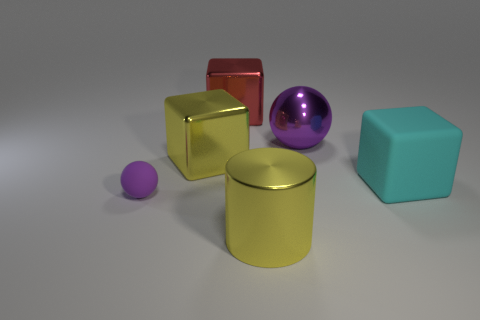Can you speculate on what the light source in the image might look like based on the reflections and shadows? Based on the reflections and shadows present in the image, the light source appears to be positioned above and to the right of the objects, as evidenced by the prominent shadows cast to the left. The light is likely soft and diffused, given the gentle shadows and subtle highlights on the objects, indicating that the source might be large or potentially filtered through a softbox or similar modifier. 